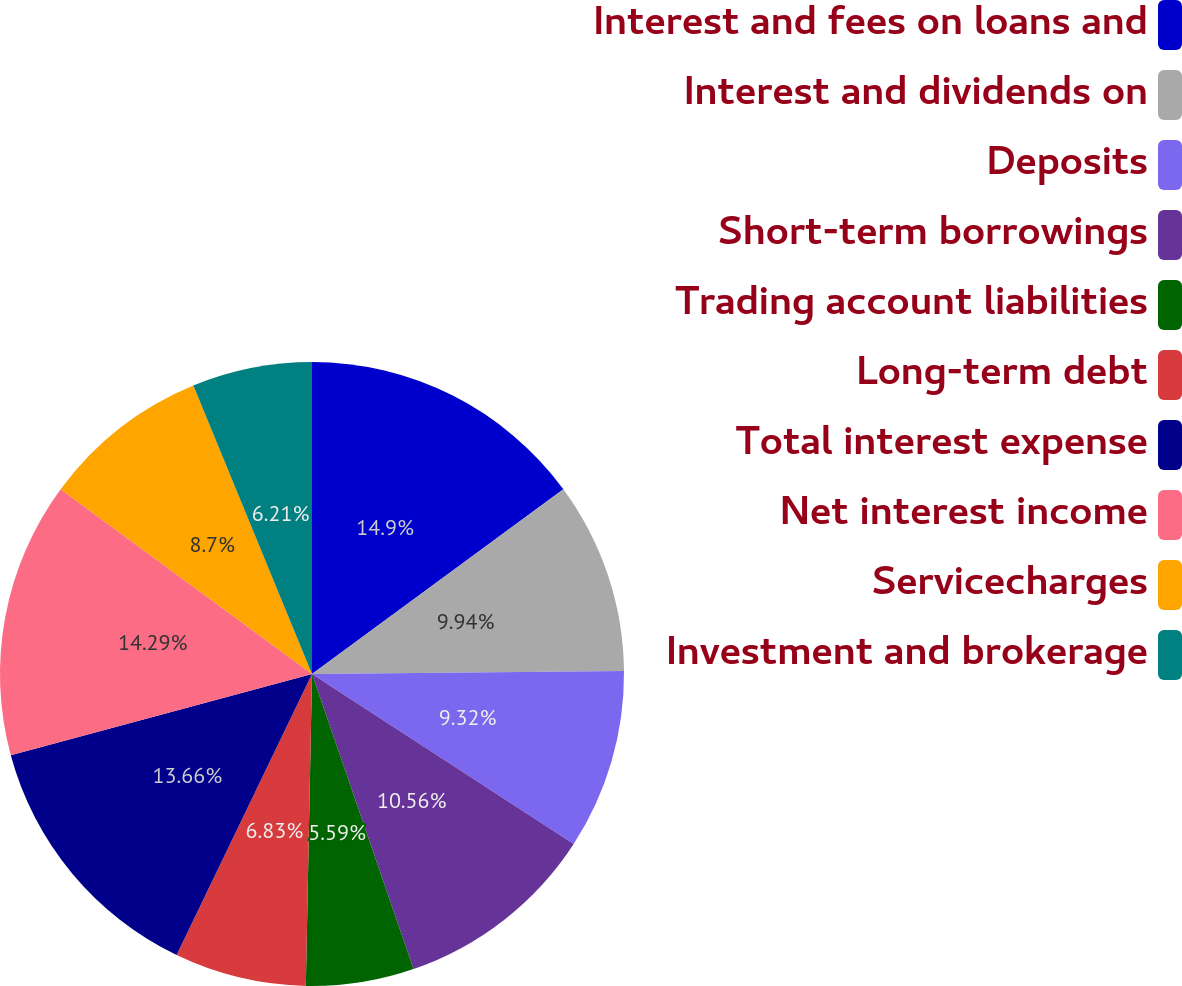Convert chart to OTSL. <chart><loc_0><loc_0><loc_500><loc_500><pie_chart><fcel>Interest and fees on loans and<fcel>Interest and dividends on<fcel>Deposits<fcel>Short-term borrowings<fcel>Trading account liabilities<fcel>Long-term debt<fcel>Total interest expense<fcel>Net interest income<fcel>Servicecharges<fcel>Investment and brokerage<nl><fcel>14.91%<fcel>9.94%<fcel>9.32%<fcel>10.56%<fcel>5.59%<fcel>6.83%<fcel>13.66%<fcel>14.29%<fcel>8.7%<fcel>6.21%<nl></chart> 